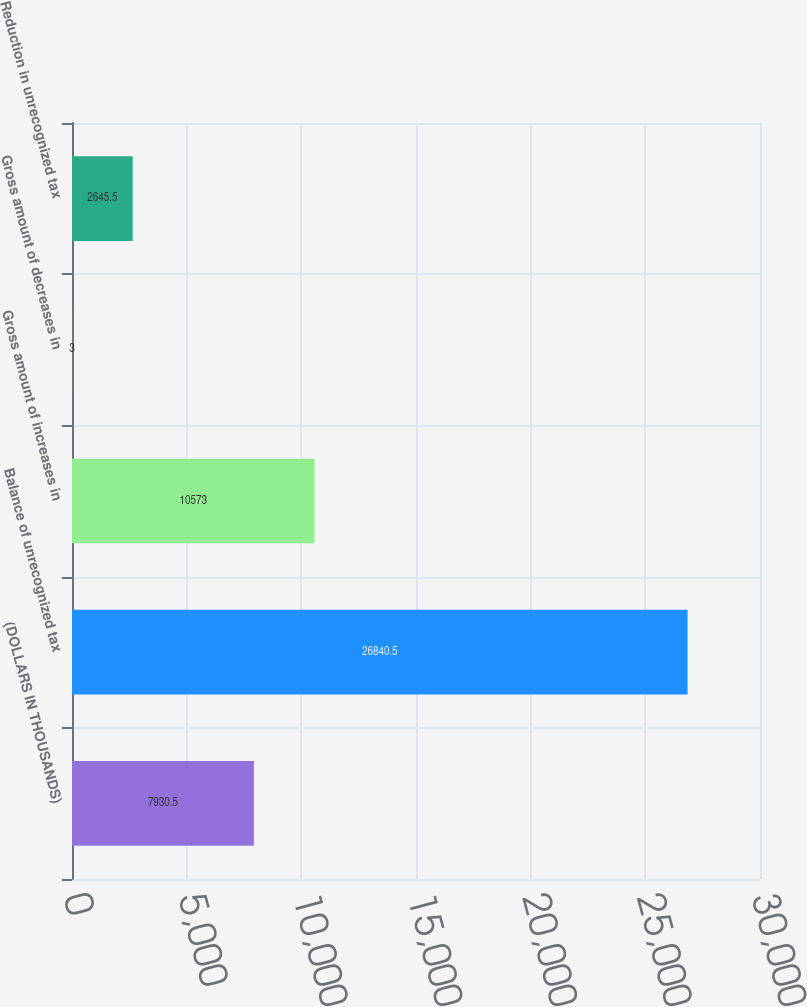Convert chart. <chart><loc_0><loc_0><loc_500><loc_500><bar_chart><fcel>(DOLLARS IN THOUSANDS)<fcel>Balance of unrecognized tax<fcel>Gross amount of increases in<fcel>Gross amount of decreases in<fcel>Reduction in unrecognized tax<nl><fcel>7930.5<fcel>26840.5<fcel>10573<fcel>3<fcel>2645.5<nl></chart> 